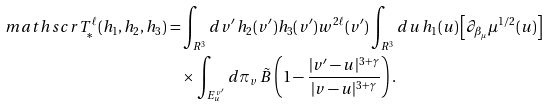<formula> <loc_0><loc_0><loc_500><loc_500>\ m a t h s c r { T } _ { \ast } ^ { \ell } ( h _ { 1 } , h _ { 2 } , h _ { 3 } ) = & \int _ { { R } ^ { 3 } } d v ^ { \prime } \, h _ { 2 } ( v ^ { \prime } ) h _ { 3 } ( v ^ { \prime } ) w ^ { 2 \ell } ( v ^ { \prime } ) \int _ { { R } ^ { 3 } } d u \, h _ { 1 } ( u ) \left [ \partial _ { \beta _ { \mu } } \mu ^ { 1 / 2 } ( u ) \right ] \\ & \times \int _ { E _ { u } ^ { v ^ { \prime } } } d \pi _ { v } \, \tilde { B } \left ( 1 - \frac { | v ^ { \prime } - u | ^ { 3 + \gamma } } { | v - u | ^ { 3 + \gamma } } \right ) .</formula> 